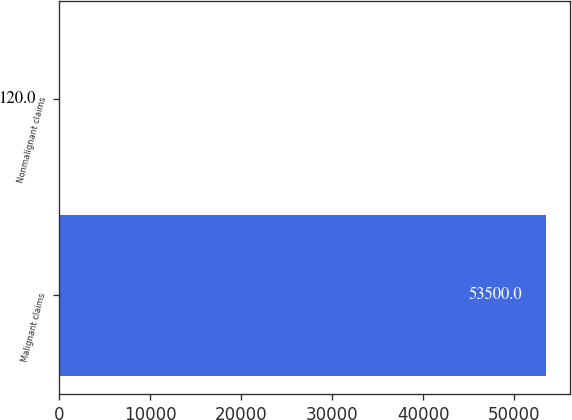Convert chart to OTSL. <chart><loc_0><loc_0><loc_500><loc_500><bar_chart><fcel>Malignant claims<fcel>Nonmalignant claims<nl><fcel>53500<fcel>120<nl></chart> 